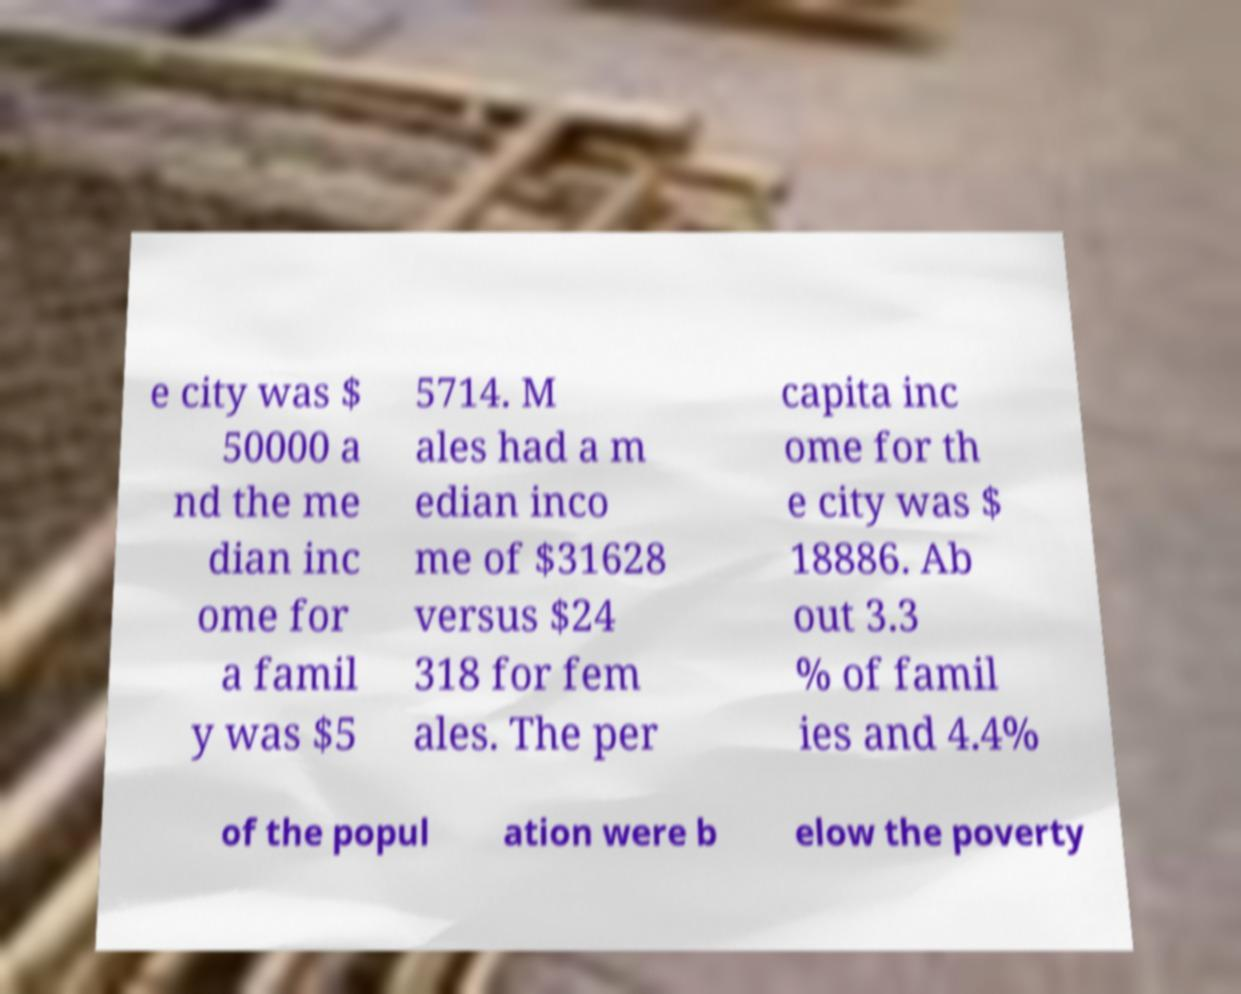Could you extract and type out the text from this image? e city was $ 50000 a nd the me dian inc ome for a famil y was $5 5714. M ales had a m edian inco me of $31628 versus $24 318 for fem ales. The per capita inc ome for th e city was $ 18886. Ab out 3.3 % of famil ies and 4.4% of the popul ation were b elow the poverty 